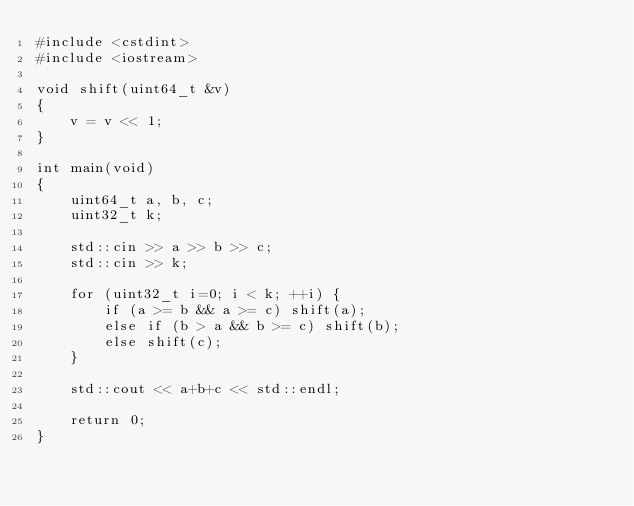Convert code to text. <code><loc_0><loc_0><loc_500><loc_500><_C++_>#include <cstdint>
#include <iostream>

void shift(uint64_t &v)
{
    v = v << 1;
}

int main(void)
{
    uint64_t a, b, c;
    uint32_t k;

    std::cin >> a >> b >> c;
    std::cin >> k;

    for (uint32_t i=0; i < k; ++i) {
        if (a >= b && a >= c) shift(a);
        else if (b > a && b >= c) shift(b);
        else shift(c);
    }

    std::cout << a+b+c << std::endl;

    return 0;
}</code> 